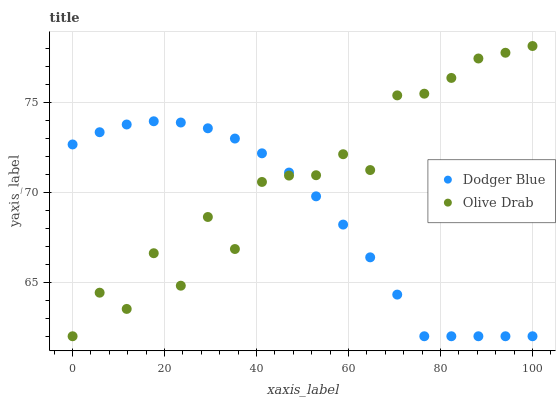Does Dodger Blue have the minimum area under the curve?
Answer yes or no. Yes. Does Olive Drab have the maximum area under the curve?
Answer yes or no. Yes. Does Olive Drab have the minimum area under the curve?
Answer yes or no. No. Is Dodger Blue the smoothest?
Answer yes or no. Yes. Is Olive Drab the roughest?
Answer yes or no. Yes. Is Olive Drab the smoothest?
Answer yes or no. No. Does Dodger Blue have the lowest value?
Answer yes or no. Yes. Does Olive Drab have the highest value?
Answer yes or no. Yes. Does Dodger Blue intersect Olive Drab?
Answer yes or no. Yes. Is Dodger Blue less than Olive Drab?
Answer yes or no. No. Is Dodger Blue greater than Olive Drab?
Answer yes or no. No. 